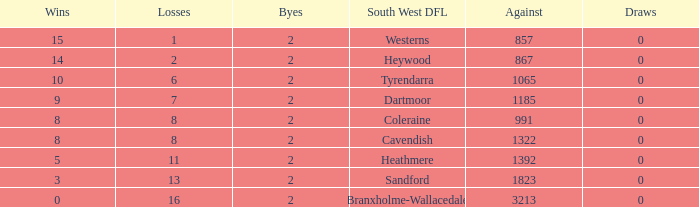How many Draws have a South West DFL of tyrendarra, and less than 10 wins? None. 